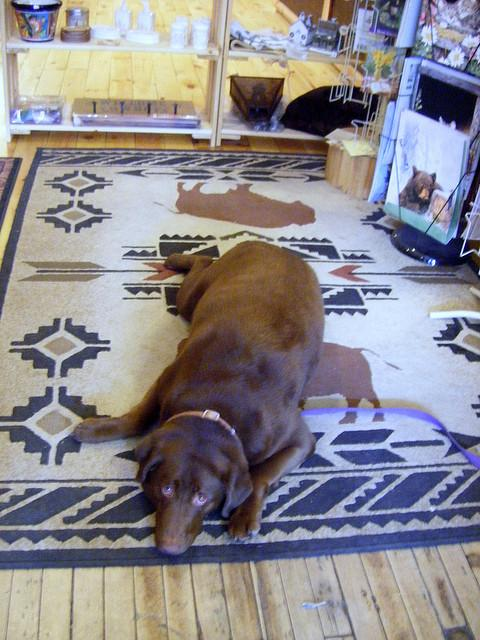What kind of dog is laying on the carpet?

Choices:
A) brown lab
B) terrier
C) pug
D) poodle brown lab 